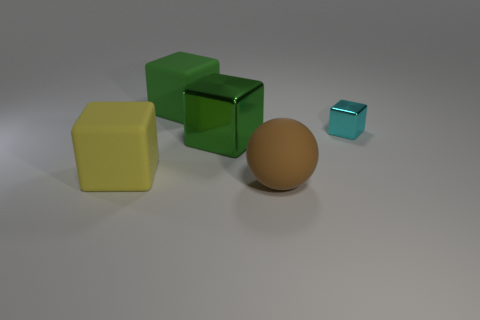What number of objects are either large cubes or big matte objects?
Give a very brief answer. 4. What size is the cyan object that is the same shape as the green shiny object?
Your response must be concise. Small. Are there more yellow things that are behind the yellow matte object than large gray matte objects?
Offer a terse response. No. Are the ball and the big yellow thing made of the same material?
Provide a short and direct response. Yes. How many objects are objects that are in front of the big yellow rubber cube or large objects in front of the cyan metal cube?
Offer a very short reply. 3. What is the color of the other matte object that is the same shape as the green matte object?
Offer a very short reply. Yellow. How many matte spheres have the same color as the tiny cube?
Keep it short and to the point. 0. Does the large matte ball have the same color as the small cube?
Offer a terse response. No. How many objects are either cubes right of the large matte sphere or big yellow matte things?
Your response must be concise. 2. What is the color of the metallic object right of the green object that is on the right side of the green matte cube to the left of the brown ball?
Your answer should be very brief. Cyan. 